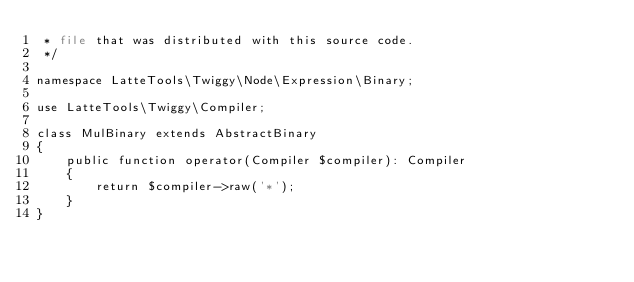Convert code to text. <code><loc_0><loc_0><loc_500><loc_500><_PHP_> * file that was distributed with this source code.
 */

namespace LatteTools\Twiggy\Node\Expression\Binary;

use LatteTools\Twiggy\Compiler;

class MulBinary extends AbstractBinary
{
	public function operator(Compiler $compiler): Compiler
	{
		return $compiler->raw('*');
	}
}
</code> 